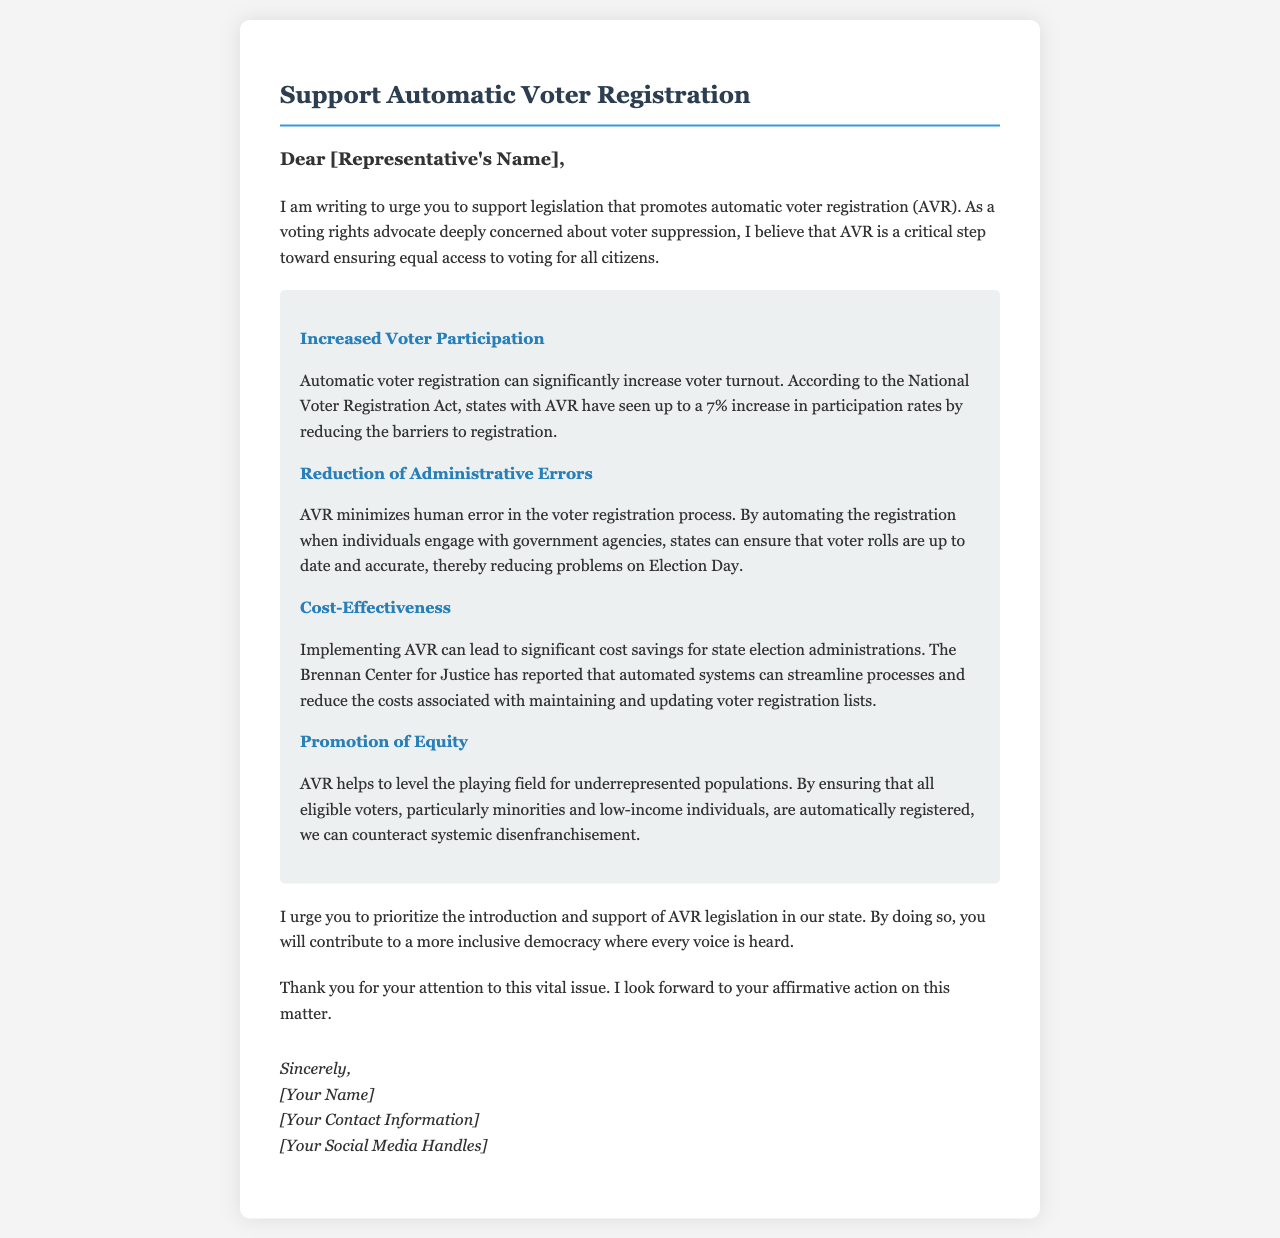What is the title of the letter? The title of the letter is indicated prominently at the top of the document.
Answer: Support Automatic Voter Registration What percentage increase in voter participation is noted with AVR? The letter states that states with AVR have seen up to a 7% increase in participation rates.
Answer: 7% Which organization is mentioned regarding cost-effectiveness? The organization is referred to in relation to cost savings from implementing AVR.
Answer: Brennan Center for Justice What is one benefit of AVR related to underrepresented populations? The letter mentions a specific benefit involving underrepresented populations, highlighting its importance.
Answer: Promotion of Equity What is the closing statement of the letter? The closing statement summarizes the author's appreciation and anticipates a positive response.
Answer: Thank you for your attention to this vital issue What is the main call to action in the letter? The letter emphasizes a specific request for legislative support.
Answer: Introduce and support AVR legislation What role does AVR play in reducing errors? The document states how AVR impacts human error in voter registration processes.
Answer: Minimizes human error What type of document is this? The content and format suggest a specific type of correspondence aimed at influencing a political figure.
Answer: Letter 